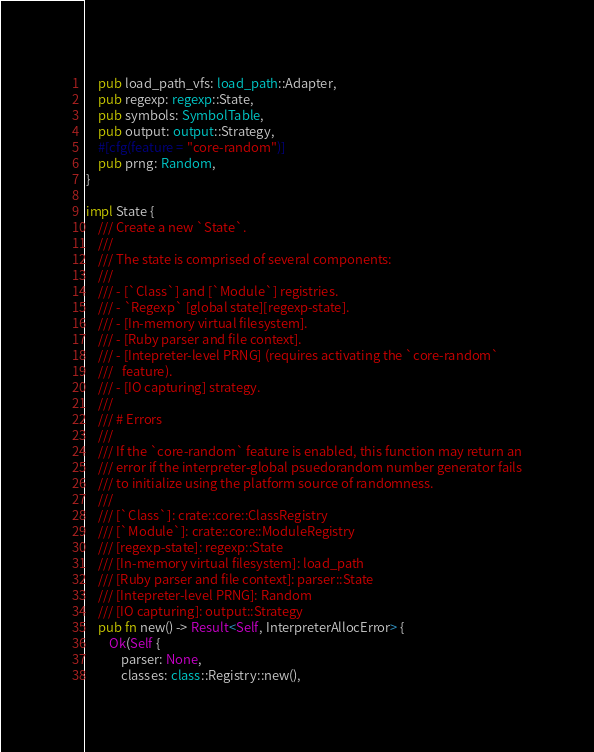Convert code to text. <code><loc_0><loc_0><loc_500><loc_500><_Rust_>    pub load_path_vfs: load_path::Adapter,
    pub regexp: regexp::State,
    pub symbols: SymbolTable,
    pub output: output::Strategy,
    #[cfg(feature = "core-random")]
    pub prng: Random,
}

impl State {
    /// Create a new `State`.
    ///
    /// The state is comprised of several components:
    ///
    /// - [`Class`] and [`Module`] registries.
    /// - `Regexp` [global state][regexp-state].
    /// - [In-memory virtual filesystem].
    /// - [Ruby parser and file context].
    /// - [Intepreter-level PRNG] (requires activating the `core-random`
    ///   feature).
    /// - [IO capturing] strategy.
    ///
    /// # Errors
    ///
    /// If the `core-random` feature is enabled, this function may return an
    /// error if the interpreter-global psuedorandom number generator fails
    /// to initialize using the platform source of randomness.
    ///
    /// [`Class`]: crate::core::ClassRegistry
    /// [`Module`]: crate::core::ModuleRegistry
    /// [regexp-state]: regexp::State
    /// [In-memory virtual filesystem]: load_path
    /// [Ruby parser and file context]: parser::State
    /// [Intepreter-level PRNG]: Random
    /// [IO capturing]: output::Strategy
    pub fn new() -> Result<Self, InterpreterAllocError> {
        Ok(Self {
            parser: None,
            classes: class::Registry::new(),</code> 